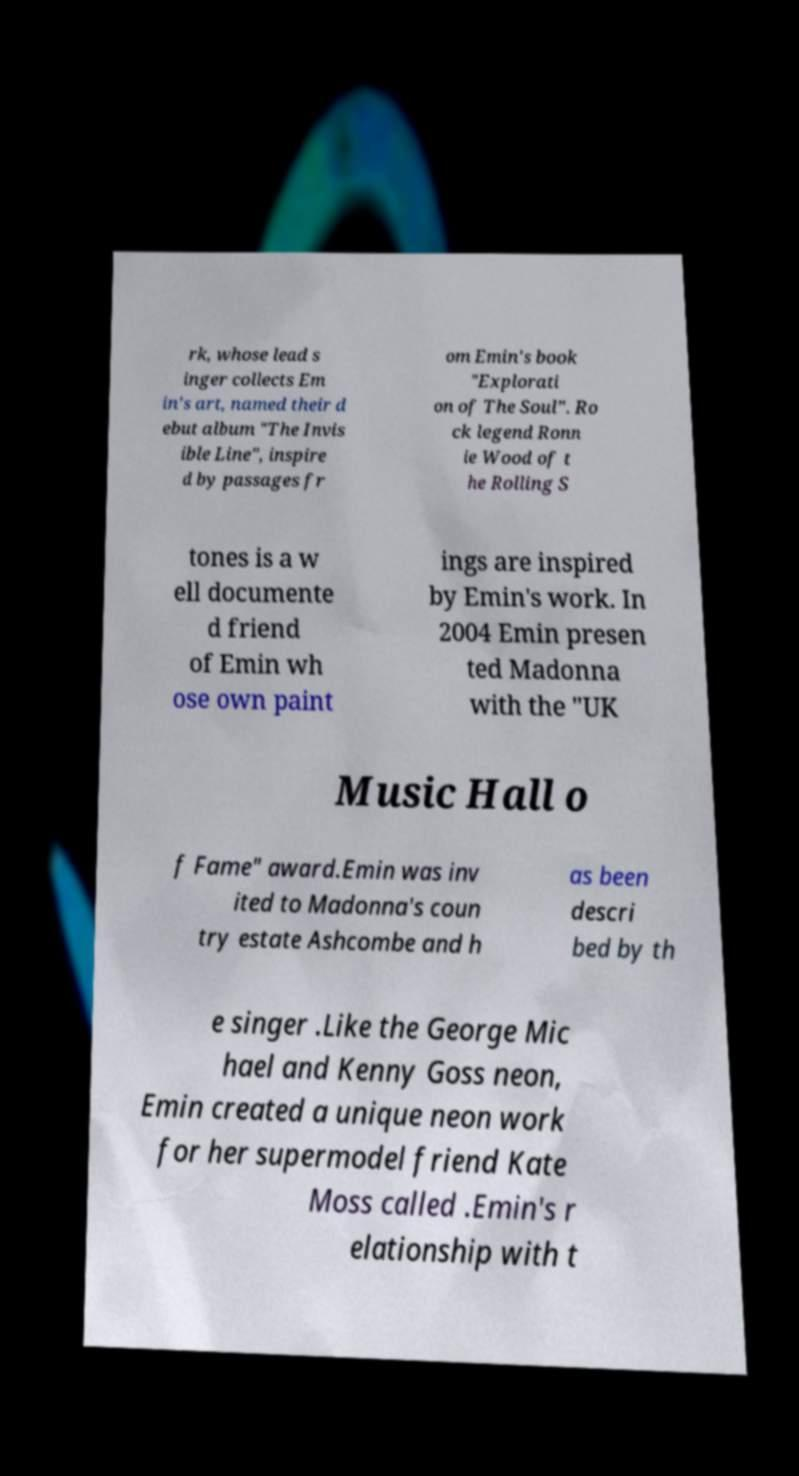Please identify and transcribe the text found in this image. rk, whose lead s inger collects Em in's art, named their d ebut album "The Invis ible Line", inspire d by passages fr om Emin's book "Explorati on of The Soul". Ro ck legend Ronn ie Wood of t he Rolling S tones is a w ell documente d friend of Emin wh ose own paint ings are inspired by Emin's work. In 2004 Emin presen ted Madonna with the "UK Music Hall o f Fame" award.Emin was inv ited to Madonna's coun try estate Ashcombe and h as been descri bed by th e singer .Like the George Mic hael and Kenny Goss neon, Emin created a unique neon work for her supermodel friend Kate Moss called .Emin's r elationship with t 